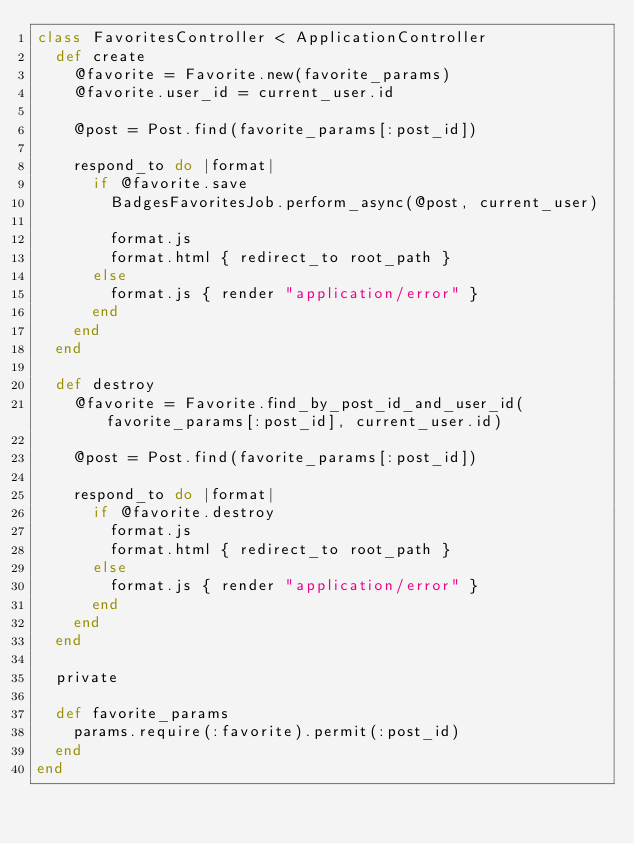<code> <loc_0><loc_0><loc_500><loc_500><_Ruby_>class FavoritesController < ApplicationController
  def create
    @favorite = Favorite.new(favorite_params)
    @favorite.user_id = current_user.id

    @post = Post.find(favorite_params[:post_id])

    respond_to do |format|
      if @favorite.save
        BadgesFavoritesJob.perform_async(@post, current_user)

        format.js
        format.html { redirect_to root_path }
      else
        format.js { render "application/error" }
      end
    end
  end

  def destroy
    @favorite = Favorite.find_by_post_id_and_user_id(favorite_params[:post_id], current_user.id)

    @post = Post.find(favorite_params[:post_id])

    respond_to do |format|
      if @favorite.destroy
        format.js
        format.html { redirect_to root_path }
      else
        format.js { render "application/error" }
      end
    end
  end

  private

  def favorite_params
    params.require(:favorite).permit(:post_id)
  end
end
</code> 